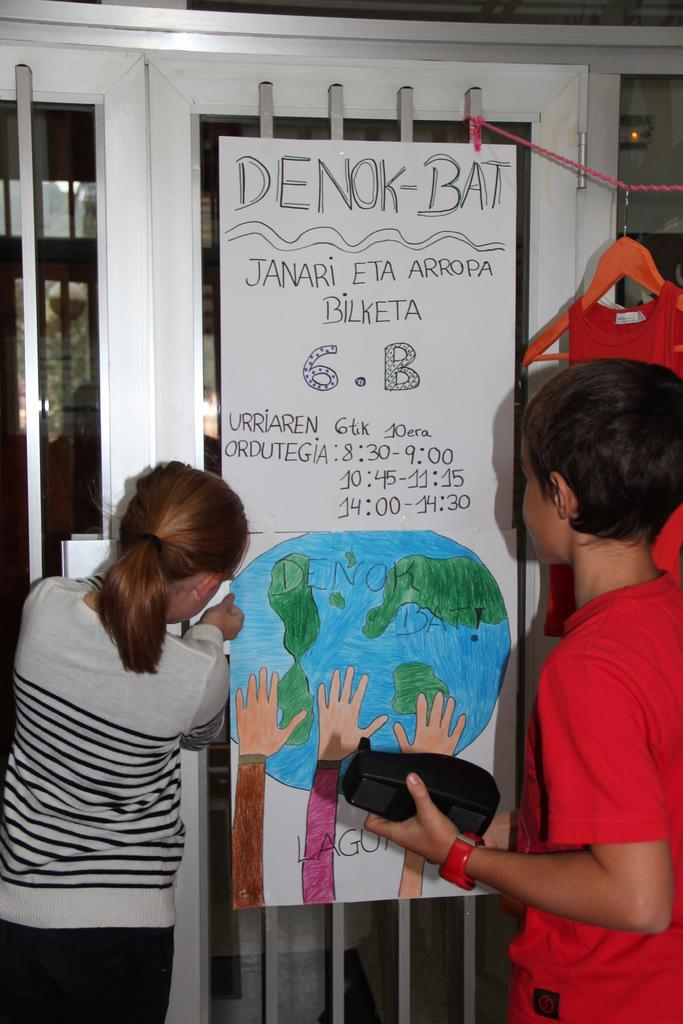How many people are in the image? There is a girl and a boy in the image. What is the boy holding in his hand? The boy is holding something in his hand, but the specific object cannot be determined from the image. Can you describe the boy's accessories? The boy is wearing a watch. What can be seen in the background of the image? There is a grille in the background of the image, and a poster is on the grille. What is written on the poster? There is writing on the poster, but the specific text cannot be determined from the image. What type of gun is the boy holding in the image? There is no gun present in the image; the boy is holding an unidentifiable object in his hand. Can you describe the boot that the girl is wearing in the image? There is no mention of boots in the image; the girl's footwear cannot be determined from the provided facts. 